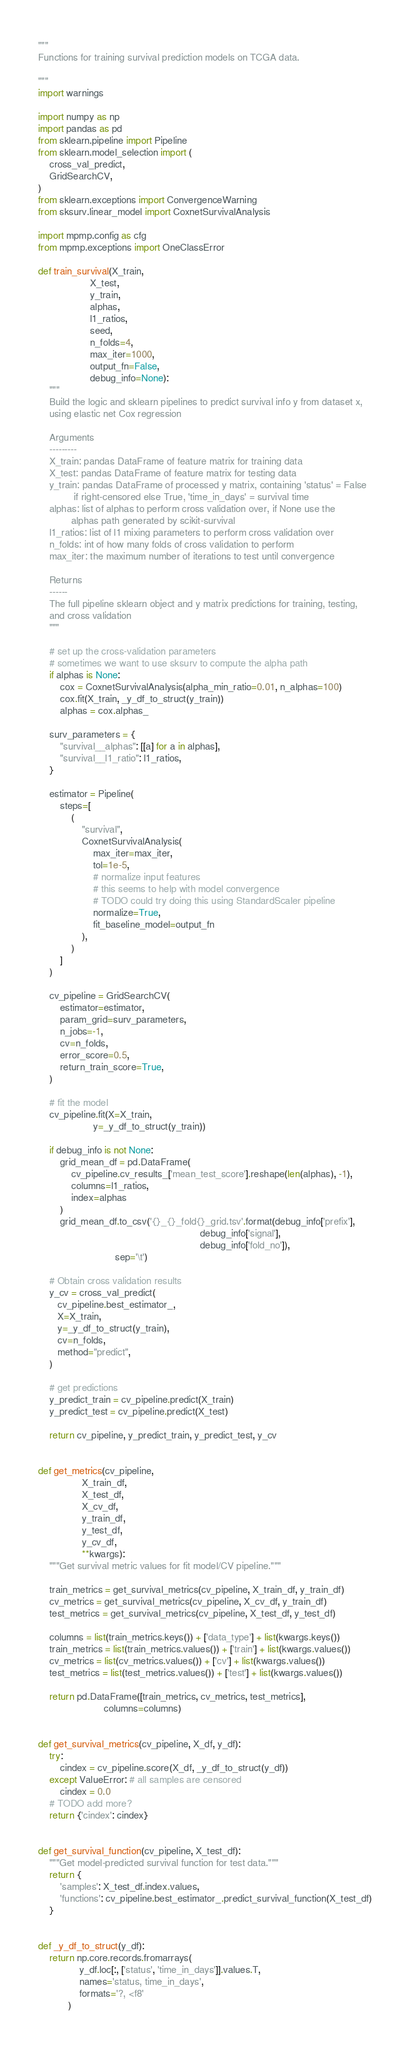<code> <loc_0><loc_0><loc_500><loc_500><_Python_>"""
Functions for training survival prediction models on TCGA data.

"""
import warnings

import numpy as np
import pandas as pd
from sklearn.pipeline import Pipeline
from sklearn.model_selection import (
    cross_val_predict,
    GridSearchCV,
)
from sklearn.exceptions import ConvergenceWarning
from sksurv.linear_model import CoxnetSurvivalAnalysis

import mpmp.config as cfg
from mpmp.exceptions import OneClassError

def train_survival(X_train,
                   X_test,
                   y_train,
                   alphas,
                   l1_ratios,
                   seed,
                   n_folds=4,
                   max_iter=1000,
                   output_fn=False,
                   debug_info=None):
    """
    Build the logic and sklearn pipelines to predict survival info y from dataset x,
    using elastic net Cox regression

    Arguments
    ---------
    X_train: pandas DataFrame of feature matrix for training data
    X_test: pandas DataFrame of feature matrix for testing data
    y_train: pandas DataFrame of processed y matrix, containing 'status' = False
             if right-censored else True, 'time_in_days' = survival time
    alphas: list of alphas to perform cross validation over, if None use the
            alphas path generated by scikit-survival
    l1_ratios: list of l1 mixing parameters to perform cross validation over
    n_folds: int of how many folds of cross validation to perform
    max_iter: the maximum number of iterations to test until convergence

    Returns
    ------
    The full pipeline sklearn object and y matrix predictions for training, testing,
    and cross validation
    """

    # set up the cross-validation parameters
    # sometimes we want to use sksurv to compute the alpha path
    if alphas is None:
        cox = CoxnetSurvivalAnalysis(alpha_min_ratio=0.01, n_alphas=100)
        cox.fit(X_train, _y_df_to_struct(y_train))
        alphas = cox.alphas_

    surv_parameters = {
        "survival__alphas": [[a] for a in alphas],
        "survival__l1_ratio": l1_ratios,
    }

    estimator = Pipeline(
        steps=[
            (
                "survival",
                CoxnetSurvivalAnalysis(
                    max_iter=max_iter,
                    tol=1e-5,
                    # normalize input features
                    # this seems to help with model convergence
                    # TODO could try doing this using StandardScaler pipeline
                    normalize=True,
                    fit_baseline_model=output_fn
                ),
            )
        ]
    )

    cv_pipeline = GridSearchCV(
        estimator=estimator,
        param_grid=surv_parameters,
        n_jobs=-1,
        cv=n_folds,
        error_score=0.5,
        return_train_score=True,
    )

    # fit the model
    cv_pipeline.fit(X=X_train,
                    y=_y_df_to_struct(y_train))

    if debug_info is not None:
        grid_mean_df = pd.DataFrame(
            cv_pipeline.cv_results_['mean_test_score'].reshape(len(alphas), -1),
            columns=l1_ratios,
            index=alphas
        )
        grid_mean_df.to_csv('{}_{}_fold{}_grid.tsv'.format(debug_info['prefix'],
                                                           debug_info['signal'],
                                                           debug_info['fold_no']),
                            sep='\t')

    # Obtain cross validation results
    y_cv = cross_val_predict(
       cv_pipeline.best_estimator_,
       X=X_train,
       y=_y_df_to_struct(y_train),
       cv=n_folds,
       method="predict",
    )

    # get predictions
    y_predict_train = cv_pipeline.predict(X_train)
    y_predict_test = cv_pipeline.predict(X_test)

    return cv_pipeline, y_predict_train, y_predict_test, y_cv


def get_metrics(cv_pipeline,
                X_train_df,
                X_test_df,
                X_cv_df,
                y_train_df,
                y_test_df,
                y_cv_df,
                **kwargs):
    """Get survival metric values for fit model/CV pipeline."""

    train_metrics = get_survival_metrics(cv_pipeline, X_train_df, y_train_df)
    cv_metrics = get_survival_metrics(cv_pipeline, X_cv_df, y_train_df)
    test_metrics = get_survival_metrics(cv_pipeline, X_test_df, y_test_df)

    columns = list(train_metrics.keys()) + ['data_type'] + list(kwargs.keys())
    train_metrics = list(train_metrics.values()) + ['train'] + list(kwargs.values())
    cv_metrics = list(cv_metrics.values()) + ['cv'] + list(kwargs.values())
    test_metrics = list(test_metrics.values()) + ['test'] + list(kwargs.values())

    return pd.DataFrame([train_metrics, cv_metrics, test_metrics],
                        columns=columns)


def get_survival_metrics(cv_pipeline, X_df, y_df):
    try:
        cindex = cv_pipeline.score(X_df, _y_df_to_struct(y_df))
    except ValueError: # all samples are censored
        cindex = 0.0
    # TODO add more?
    return {'cindex': cindex}


def get_survival_function(cv_pipeline, X_test_df):
    """Get model-predicted survival function for test data."""
    return {
        'samples': X_test_df.index.values,
        'functions': cv_pipeline.best_estimator_.predict_survival_function(X_test_df)
    }


def _y_df_to_struct(y_df):
    return np.core.records.fromarrays(
               y_df.loc[:, ['status', 'time_in_days']].values.T,
               names='status, time_in_days',
               formats='?, <f8'
           )
</code> 